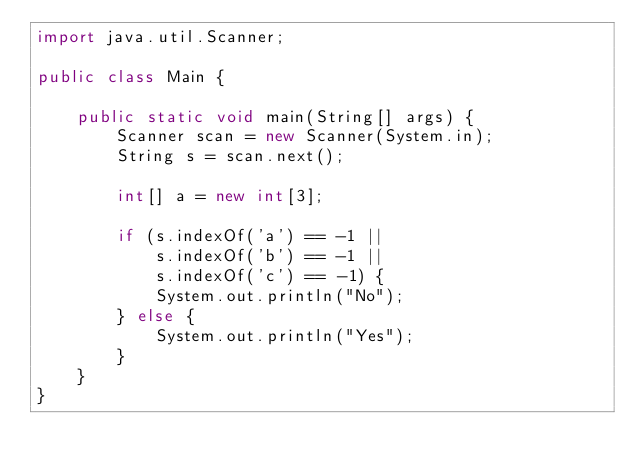<code> <loc_0><loc_0><loc_500><loc_500><_Java_>import java.util.Scanner;

public class Main {

    public static void main(String[] args) {
        Scanner scan = new Scanner(System.in);
        String s = scan.next();

        int[] a = new int[3];

        if (s.indexOf('a') == -1 ||
            s.indexOf('b') == -1 ||
            s.indexOf('c') == -1) {
            System.out.println("No");
        } else {
            System.out.println("Yes");
        }
    }
}
</code> 